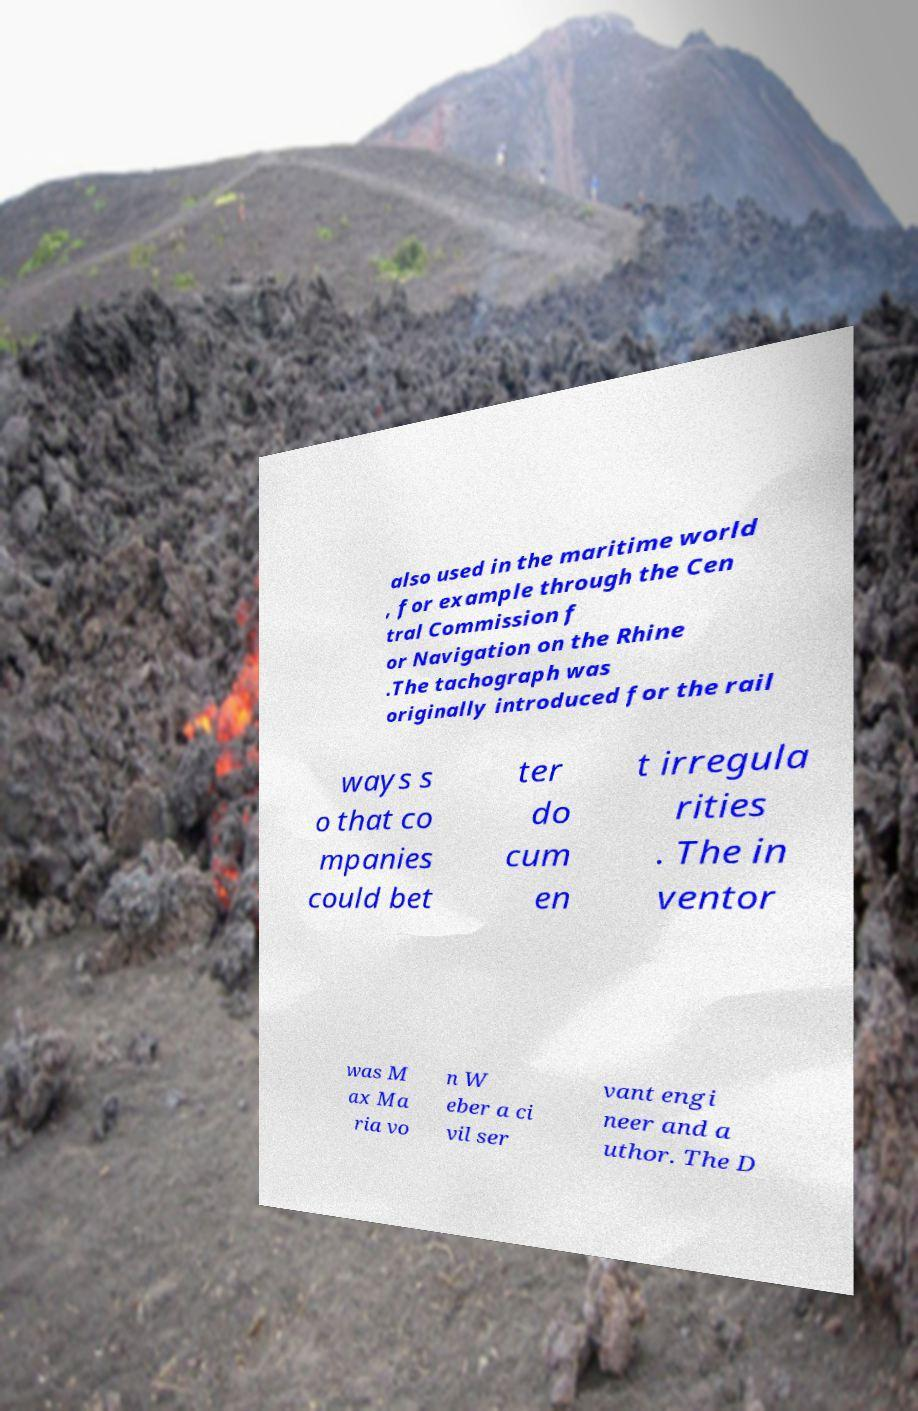For documentation purposes, I need the text within this image transcribed. Could you provide that? also used in the maritime world , for example through the Cen tral Commission f or Navigation on the Rhine .The tachograph was originally introduced for the rail ways s o that co mpanies could bet ter do cum en t irregula rities . The in ventor was M ax Ma ria vo n W eber a ci vil ser vant engi neer and a uthor. The D 